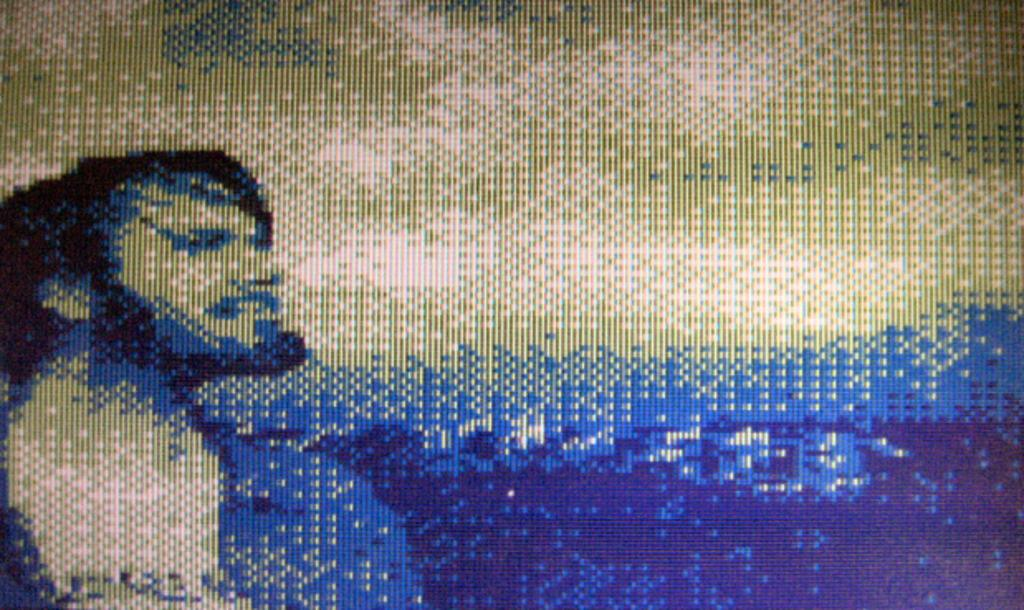What is the main subject in the foreground of the image? There is a man in the foreground of the image. Can you describe the background of the image? There might be trees in the background of the image. What type of rock is the man holding in his ear in the image? There is no rock present in the image, nor is the man holding anything in his ear. 